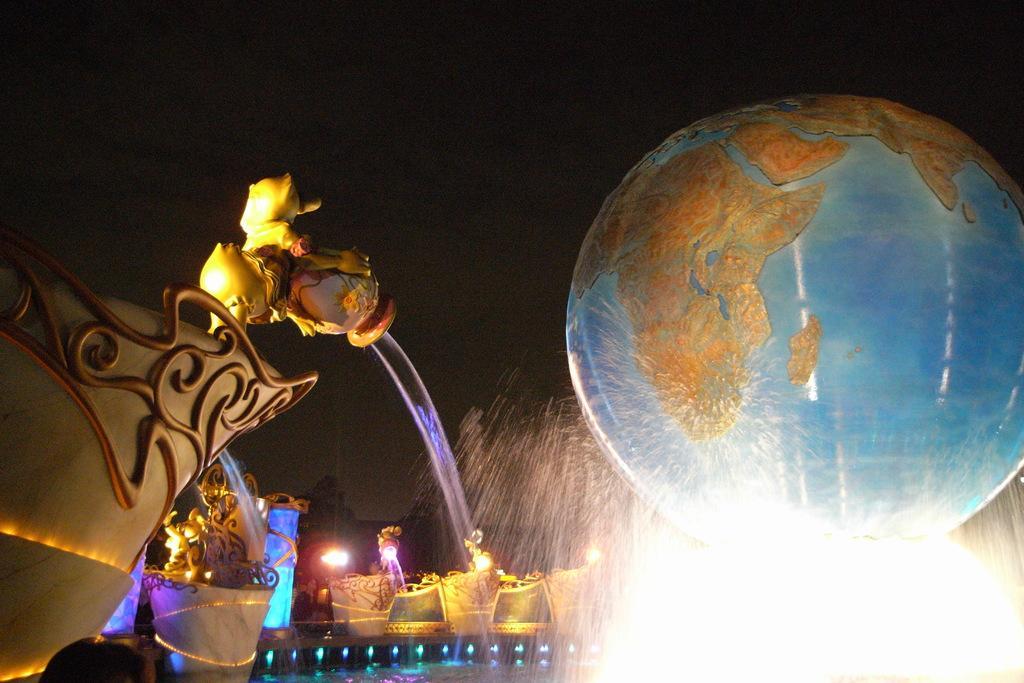Can you describe this image briefly? In this image there is a waterfall, behind the waterfall there is globe. 